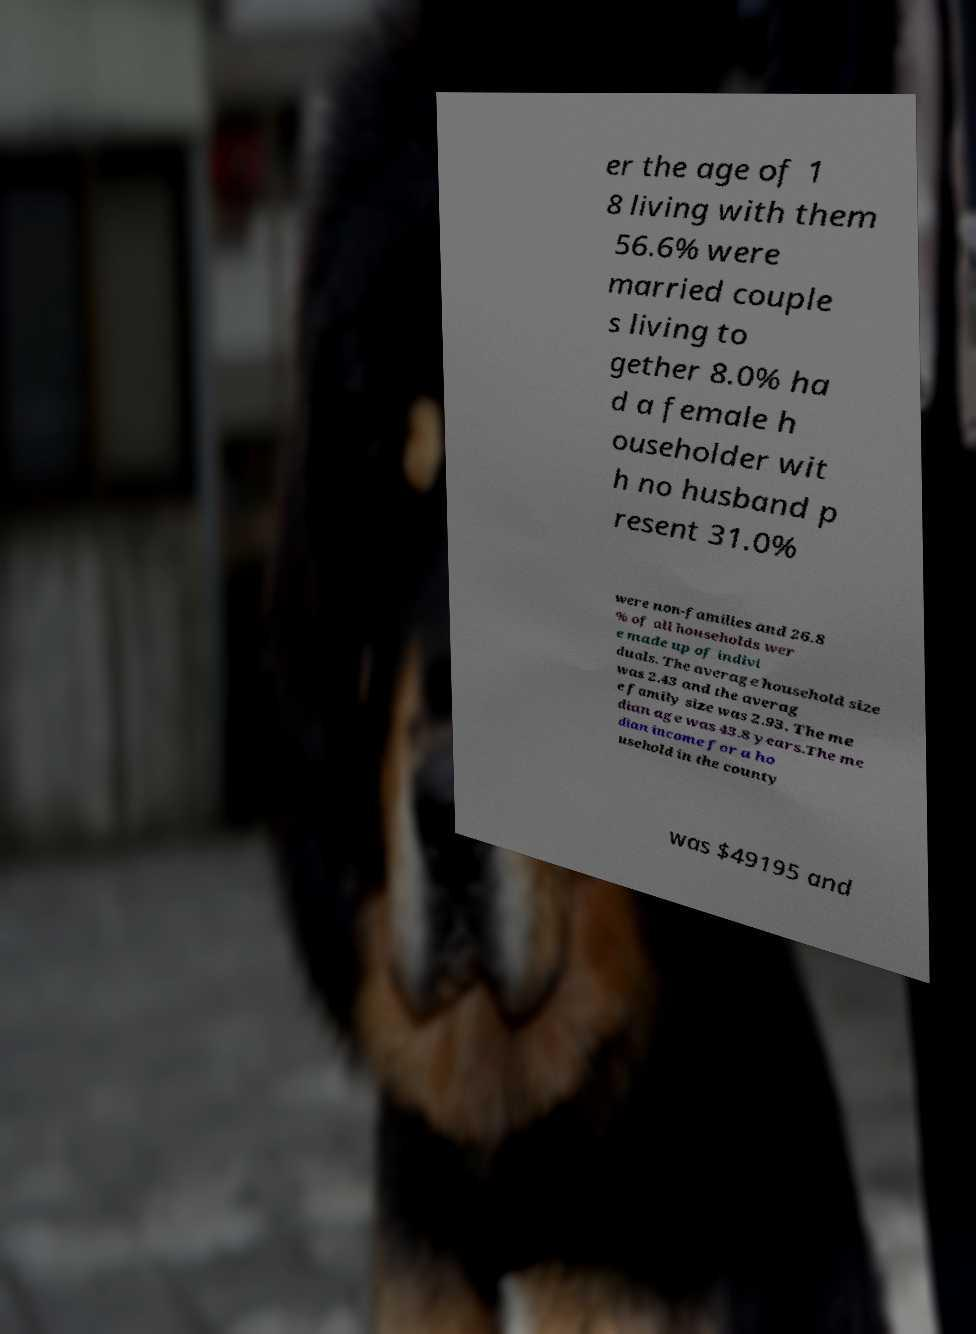Please read and relay the text visible in this image. What does it say? er the age of 1 8 living with them 56.6% were married couple s living to gether 8.0% ha d a female h ouseholder wit h no husband p resent 31.0% were non-families and 26.8 % of all households wer e made up of indivi duals. The average household size was 2.43 and the averag e family size was 2.93. The me dian age was 43.8 years.The me dian income for a ho usehold in the county was $49195 and 